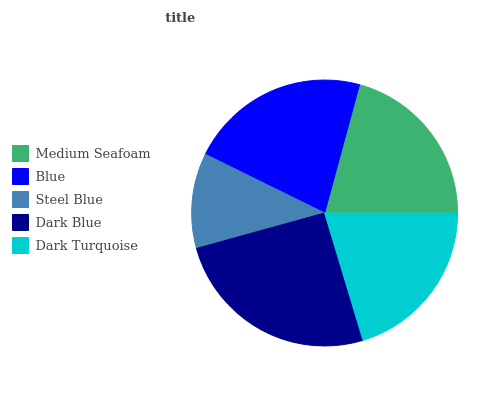Is Steel Blue the minimum?
Answer yes or no. Yes. Is Dark Blue the maximum?
Answer yes or no. Yes. Is Blue the minimum?
Answer yes or no. No. Is Blue the maximum?
Answer yes or no. No. Is Blue greater than Medium Seafoam?
Answer yes or no. Yes. Is Medium Seafoam less than Blue?
Answer yes or no. Yes. Is Medium Seafoam greater than Blue?
Answer yes or no. No. Is Blue less than Medium Seafoam?
Answer yes or no. No. Is Medium Seafoam the high median?
Answer yes or no. Yes. Is Medium Seafoam the low median?
Answer yes or no. Yes. Is Blue the high median?
Answer yes or no. No. Is Blue the low median?
Answer yes or no. No. 